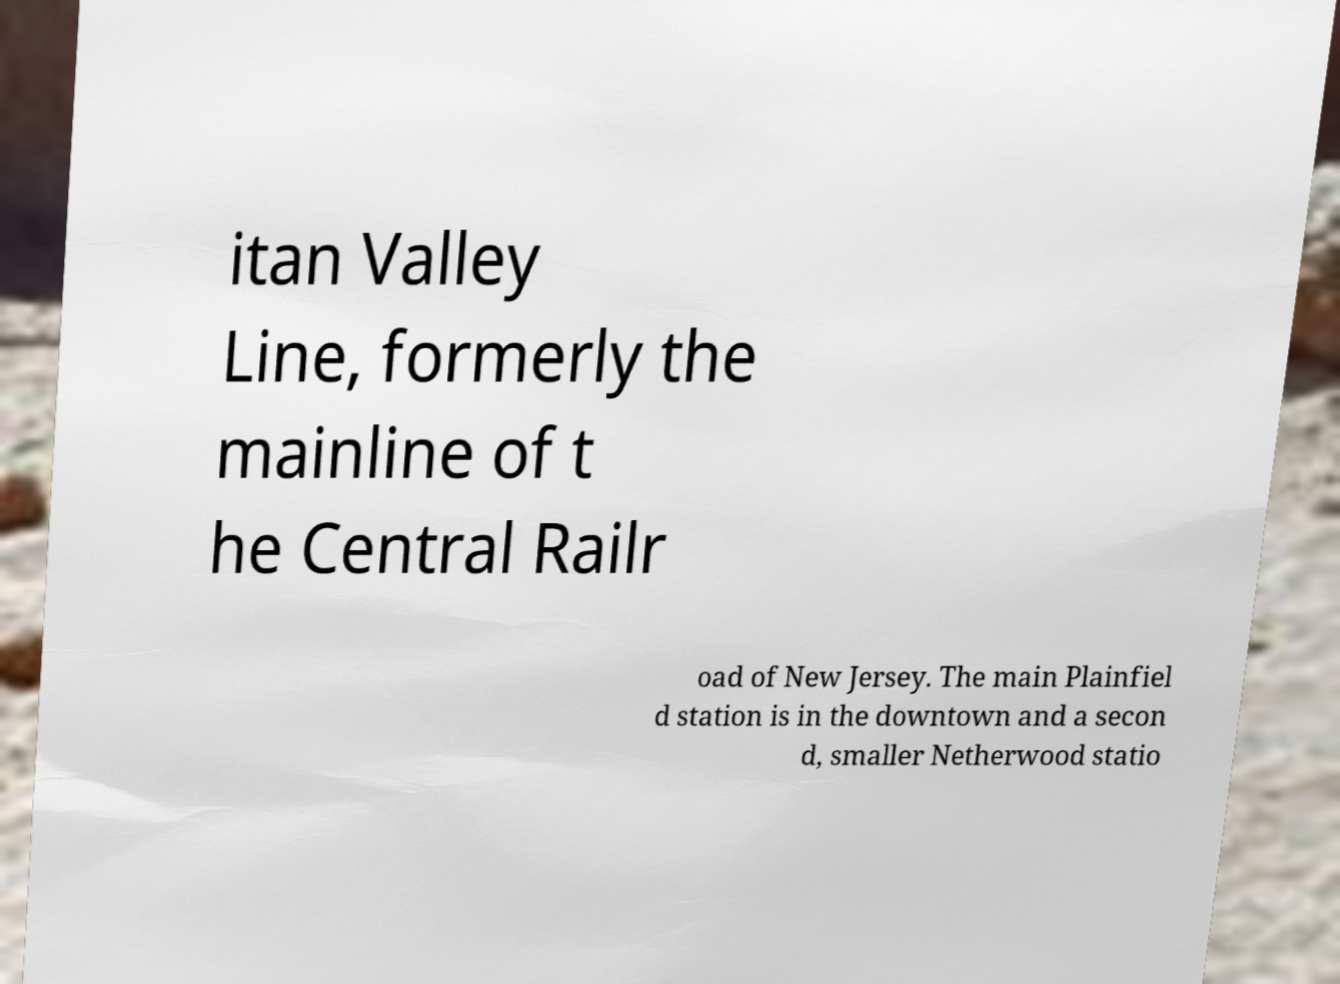Can you read and provide the text displayed in the image?This photo seems to have some interesting text. Can you extract and type it out for me? itan Valley Line, formerly the mainline of t he Central Railr oad of New Jersey. The main Plainfiel d station is in the downtown and a secon d, smaller Netherwood statio 